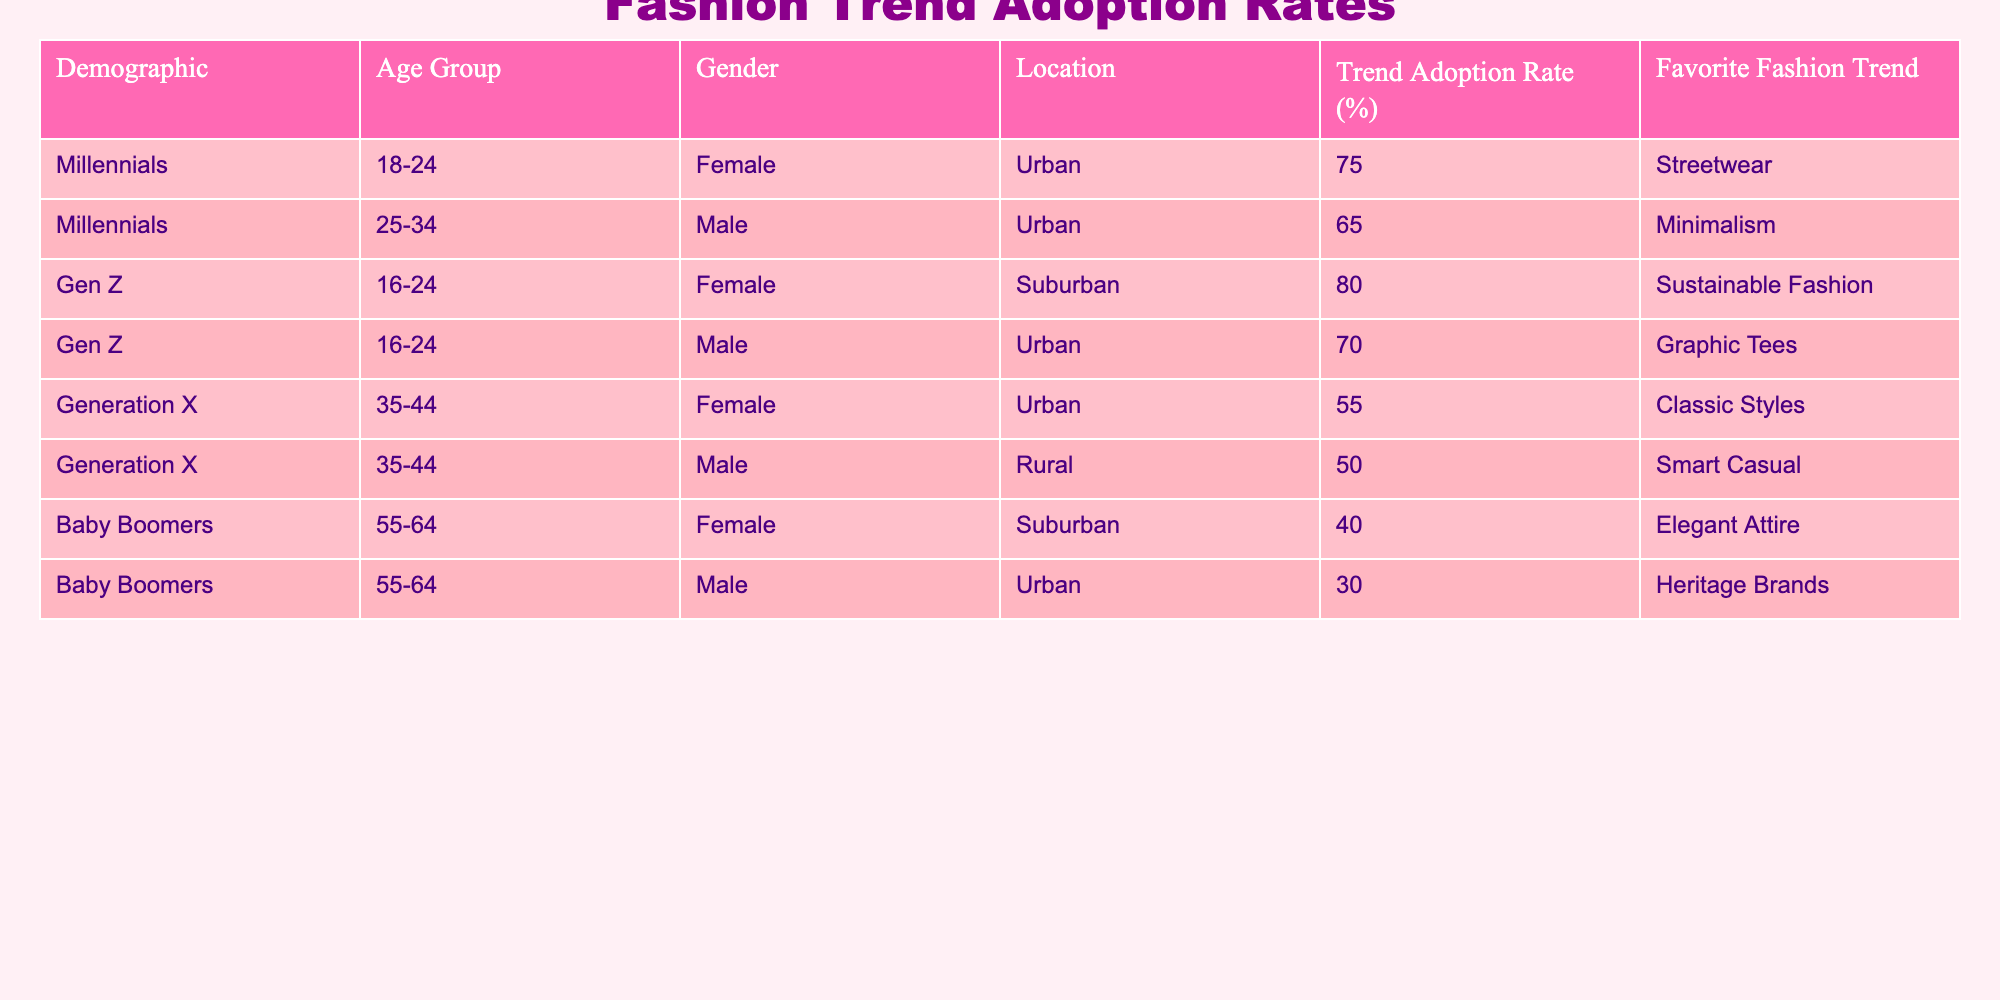What is the trend adoption rate for Millennials aged 18-24? The table lists the trend adoption rates, and under the Millennials, the row for the age group 18-24 indicates a rate of 75%.
Answer: 75% Which demographic has the highest trend adoption rate? By reviewing the table, the highest rate is found in the Gen Z demographic (16-24 years female), which has a rate of 80%.
Answer: 80% Is the trend adoption rate for Baby Boomers generally lower than that for Generation X? The table shows that Baby Boomers have a maximum adoption rate of 40%, while Generation X has a maximum of 55%, hence Baby Boomers' rates are lower.
Answer: Yes What is the combined trend adoption rate for Urban males across all age groups? The rates for Urban males are 65% (Millennials), 70% (Gen Z), and 30% (Baby Boomers). Adding them gives 65 + 70 + 30 = 165%. Since there are 3 groups, the average is 165/3 = 55%.
Answer: 55% What is the preferred fashion trend for the demographic with the lowest adoption rate? The demographic with the lowest adoption rate is Baby Boomers, with a male rate of 30%, and their favorite trend is Heritage Brands.
Answer: Heritage Brands What is the average trend adoption rate for females across all demographics? From the table, the female rates are 75% (Millennials), 55% (Generation X), 40% (Baby Boomers). Calculating the average: (75 + 55 + 40) / 3 = 170 / 3 = approximately 56.67%.
Answer: 56.67% Are there more males or females in the dataset with a trend adoption rate above 60%? Analyzing the table shows that two females (Millennials at 75% and Gen Z at 80%) have rates above 60%, while one male (Gen Z at 70%) does. Thus, there are more females.
Answer: Yes What is the trend adoption rate difference between the oldest (Baby Boomers) and the youngest (Gen Z) demographics? The Baby Boomers have a maximum rate of 40%, while Gen Z has a maximum of 80%. The difference is 80 - 40 = 40%.
Answer: 40% 